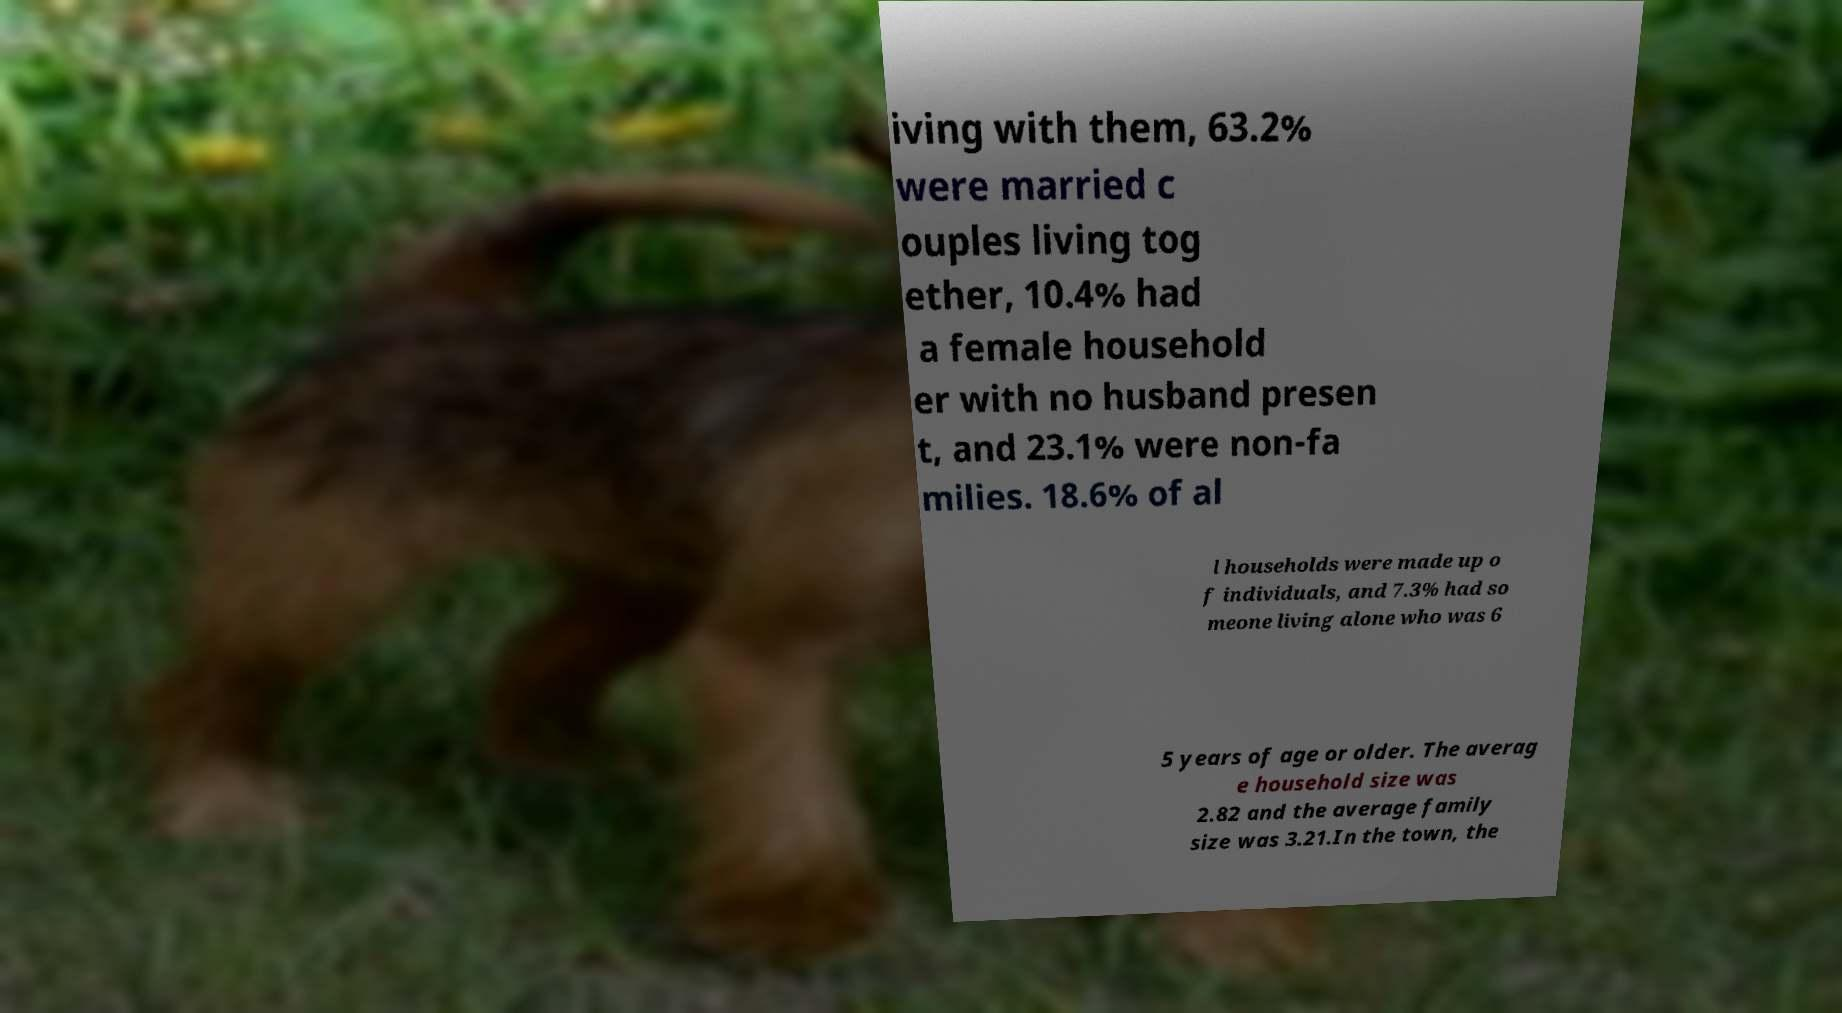Please identify and transcribe the text found in this image. iving with them, 63.2% were married c ouples living tog ether, 10.4% had a female household er with no husband presen t, and 23.1% were non-fa milies. 18.6% of al l households were made up o f individuals, and 7.3% had so meone living alone who was 6 5 years of age or older. The averag e household size was 2.82 and the average family size was 3.21.In the town, the 